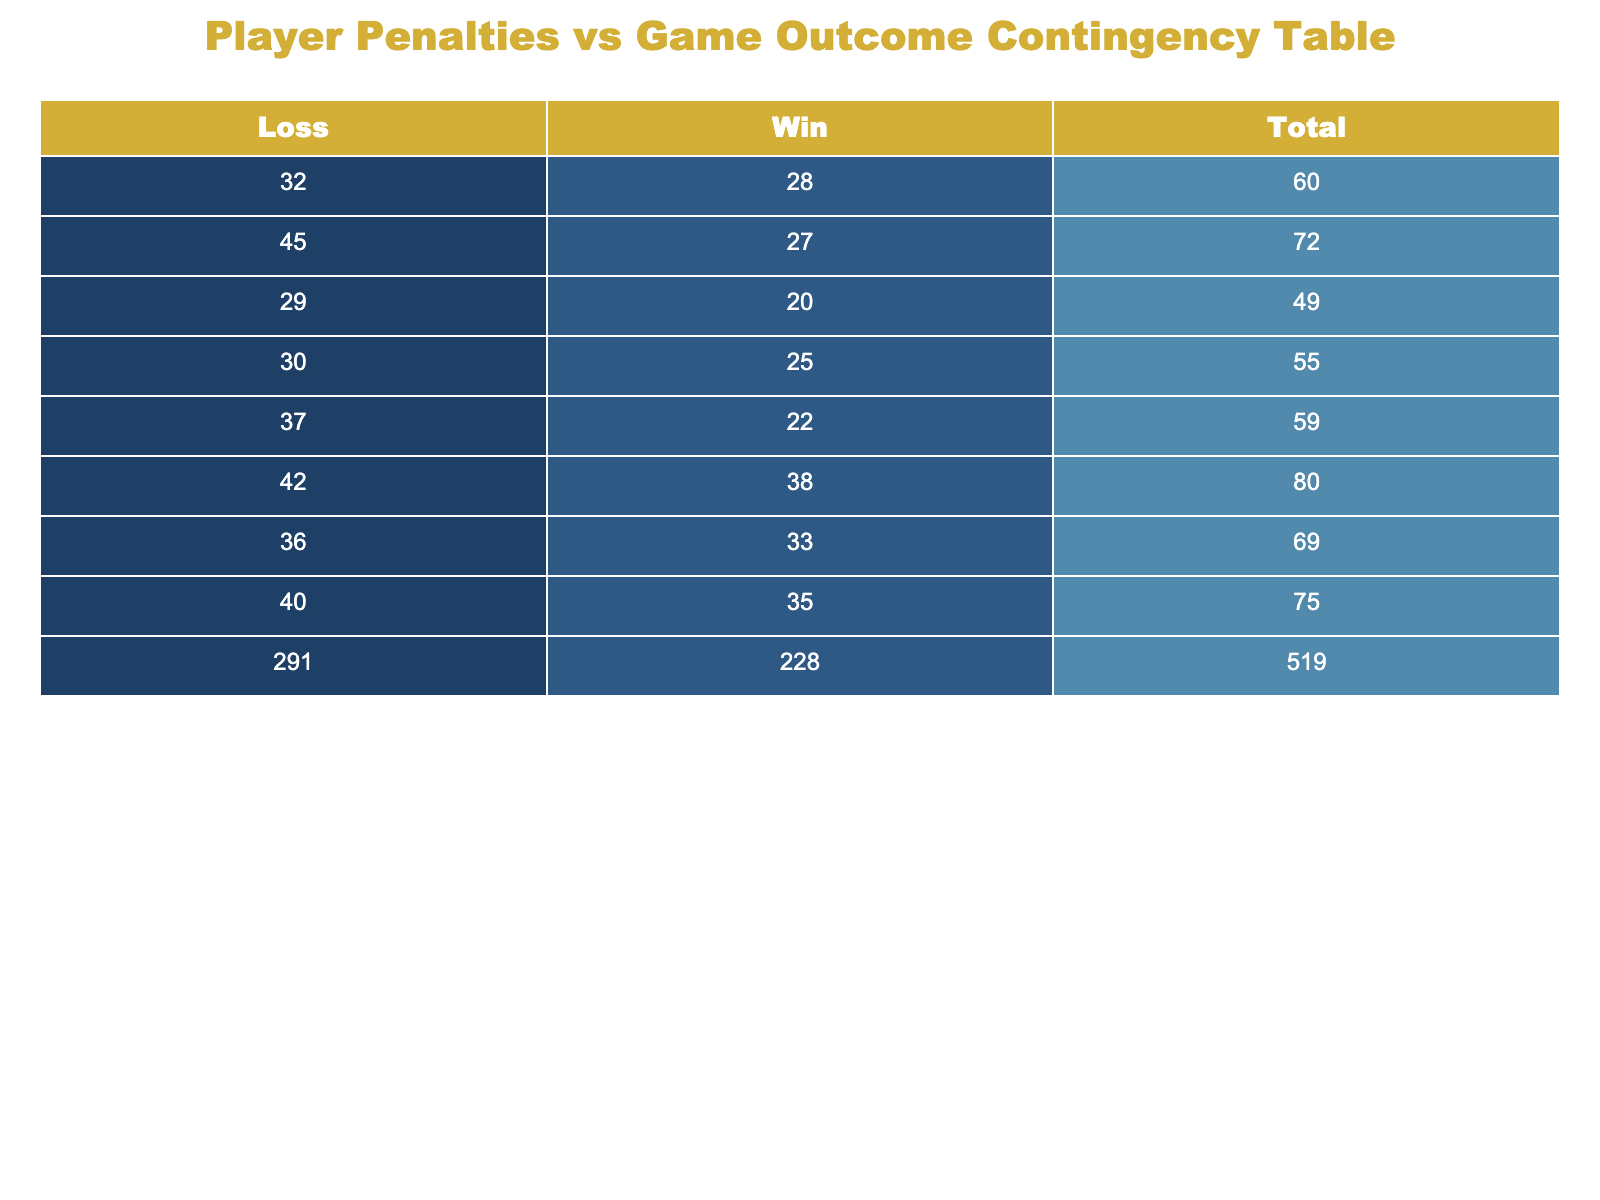What is the total number of player penalties for the New York Rangers? From the table, we can see the New York Rangers have two entries: 38 penalties for a Win and 42 penalties for a Loss. Adding these together gives us a total of 38 + 42 = 80 penalties.
Answer: 80 Which team had the highest number of player penalties resulting in a Loss? Looking at the Loss outcomes, the teams with penalties are: Toronto Maple Leafs (40), Montreal Canadiens (30), Boston Bruins (32), Chicago Blackhawks (45), Pittsburgh Penguins (36), Los Angeles Kings (29), New York Rangers (42), and Nashville Predators (37). The highest number of penalties for a Loss is from the Chicago Blackhawks with 45.
Answer: Chicago Blackhawks How many games did the Boston Bruins win compared to the number of penalties they had? The Boston Bruins won 28 penalties. There are two outcomes for them - they had 28 penalties in their Win and 32 in their Loss. Therefore, the Bruins had more wins (1) than penalties in a Win (28) because they only lost 1 game with 32 penalties.
Answer: 1 Win, 28 Penalties Is it true that the Nashville Predators’ total penalties are less than the average penalties of all teams with losses? First, we need to find the total penalties for Nashville Predators, which is 22 for a Win plus 37 for a Loss, totaling 59 penalties. Next, we calculate the average penalties of teams with losses: Sum of all losing penalties (40+30+32+45+36+29+42+37) = 319, and there are 8 teams, so average penalties = 319/8 = 39.875. Since 59 is greater than 39.875, the statement is false.
Answer: False What is the difference between the total player penalties of winning and losing games for the Montreal Canadiens? The Montreal Canadiens have 25 player penalties for Wins and 30 for Losses. To find the difference, subtract the Wins from the Losses: 30 - 25 = 5.
Answer: 5 